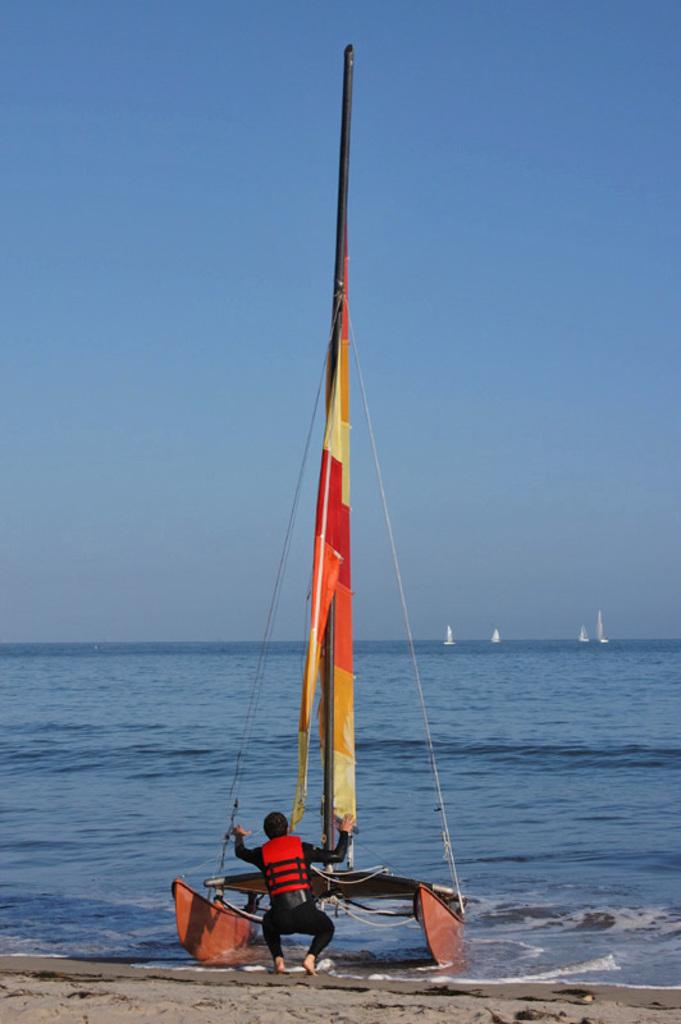What can be seen in the picture? There are two boats in the picture. What is the man between the boats doing? The man is doing some work. What feature do the boats have? The boats have masts attached to them. What is the primary setting of the image? There is a large water surface visible in the image. What type of cover is the man using to protect himself from the sun in the image? There is no cover visible in the image; the man is not shown using any protective gear against the sun. 